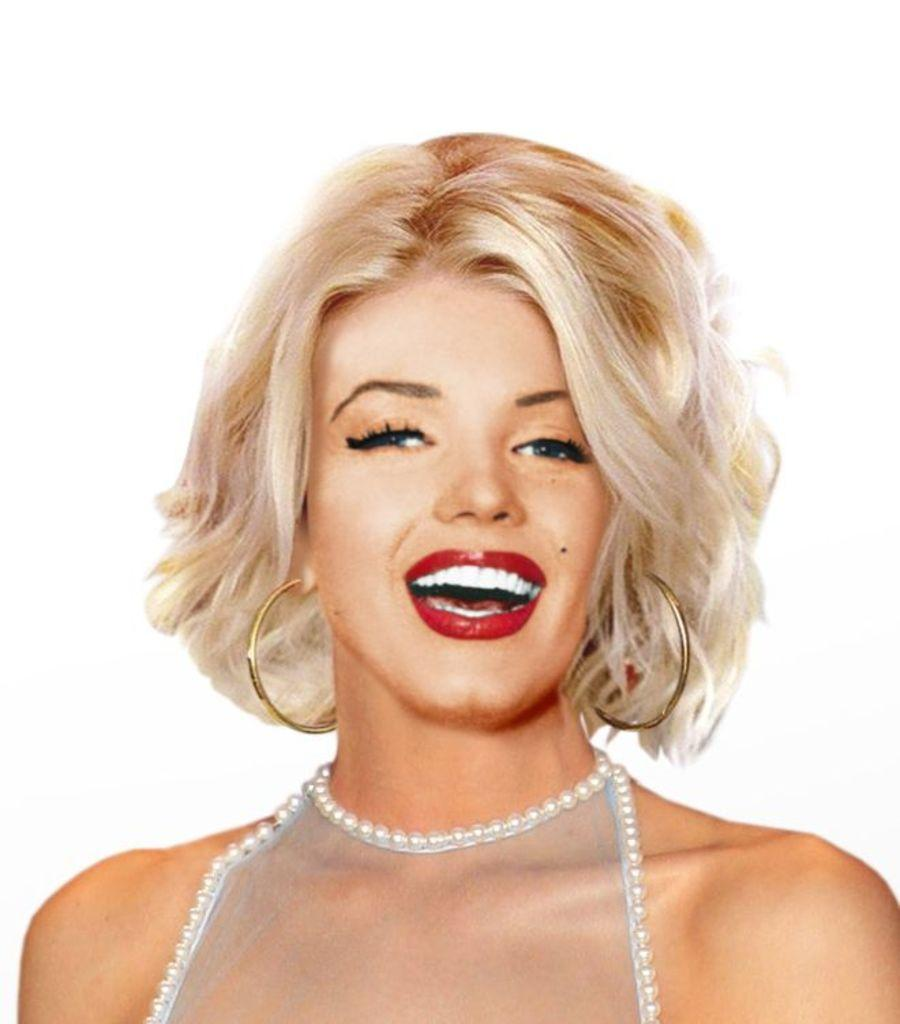Who is the main subject in the image? There is a woman in the picture. What is the woman doing with her mouth? The woman has her mouth open. What expression does the woman have on her face? The woman is smiling. What color is the background of the image? The background of the image is white. How many pins are holding the woman's hair in the image? There are no pins visible in the image; the woman's hair is not mentioned in the provided facts. 